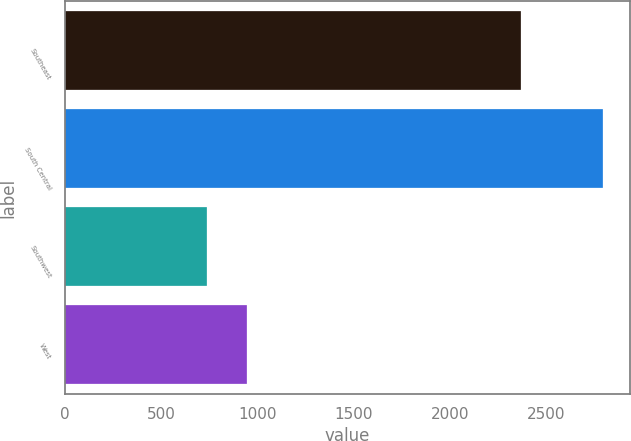<chart> <loc_0><loc_0><loc_500><loc_500><bar_chart><fcel>Southeast<fcel>South Central<fcel>Southwest<fcel>West<nl><fcel>2369<fcel>2794<fcel>738<fcel>943.6<nl></chart> 